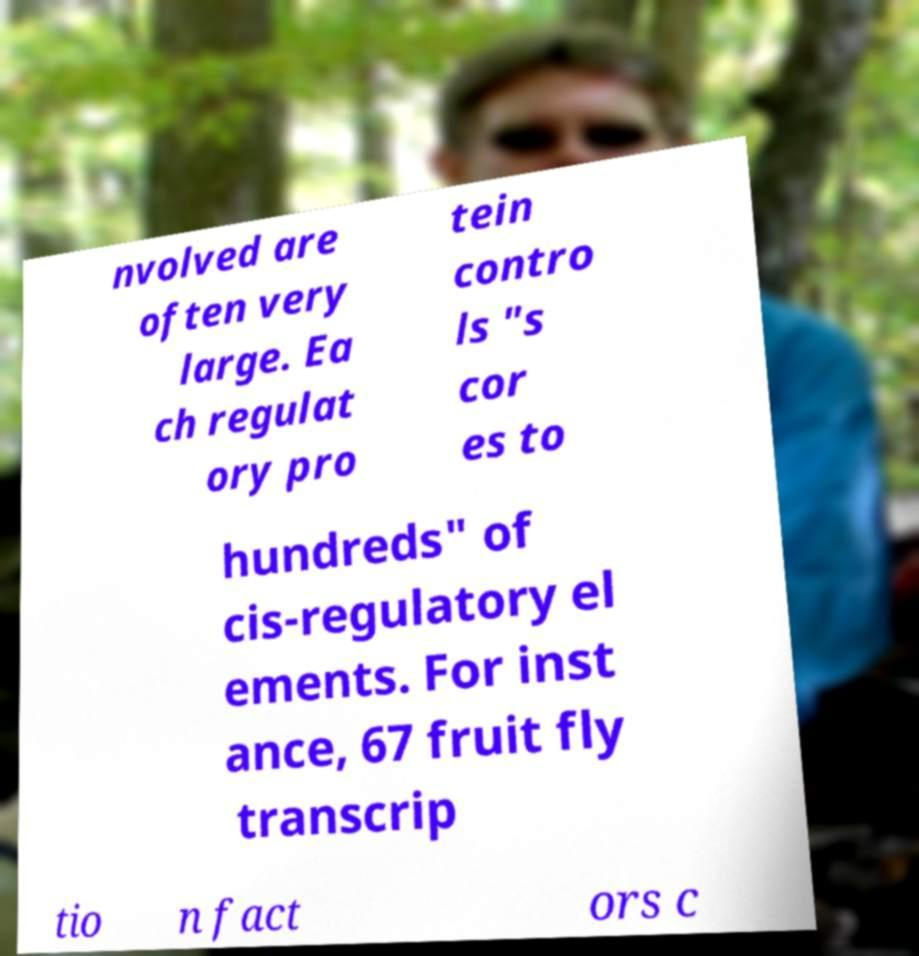I need the written content from this picture converted into text. Can you do that? nvolved are often very large. Ea ch regulat ory pro tein contro ls "s cor es to hundreds" of cis-regulatory el ements. For inst ance, 67 fruit fly transcrip tio n fact ors c 